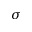Convert formula to latex. <formula><loc_0><loc_0><loc_500><loc_500>\sigma</formula> 